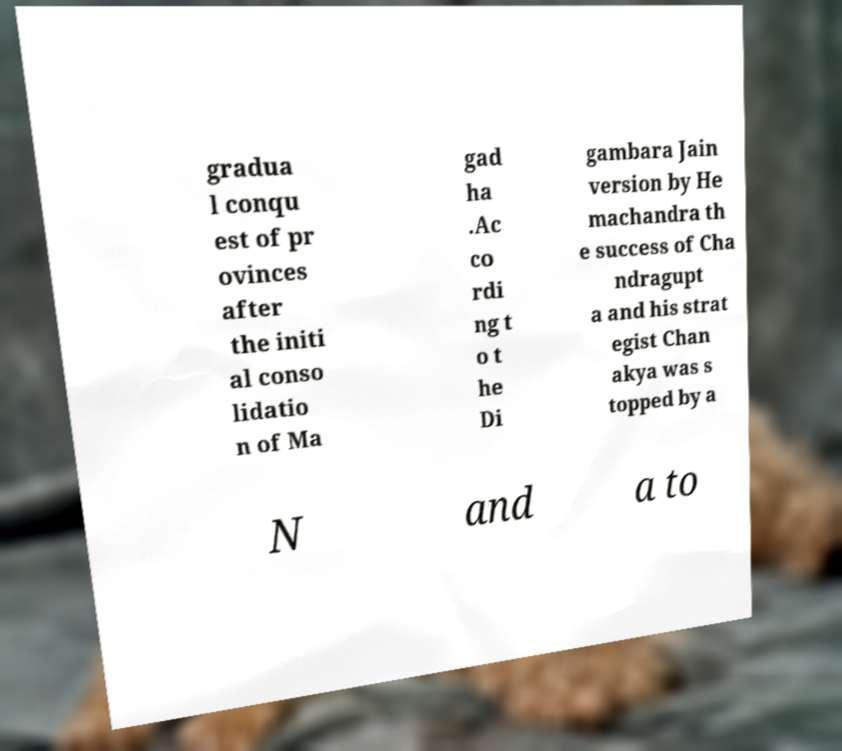I need the written content from this picture converted into text. Can you do that? gradua l conqu est of pr ovinces after the initi al conso lidatio n of Ma gad ha .Ac co rdi ng t o t he Di gambara Jain version by He machandra th e success of Cha ndragupt a and his strat egist Chan akya was s topped by a N and a to 